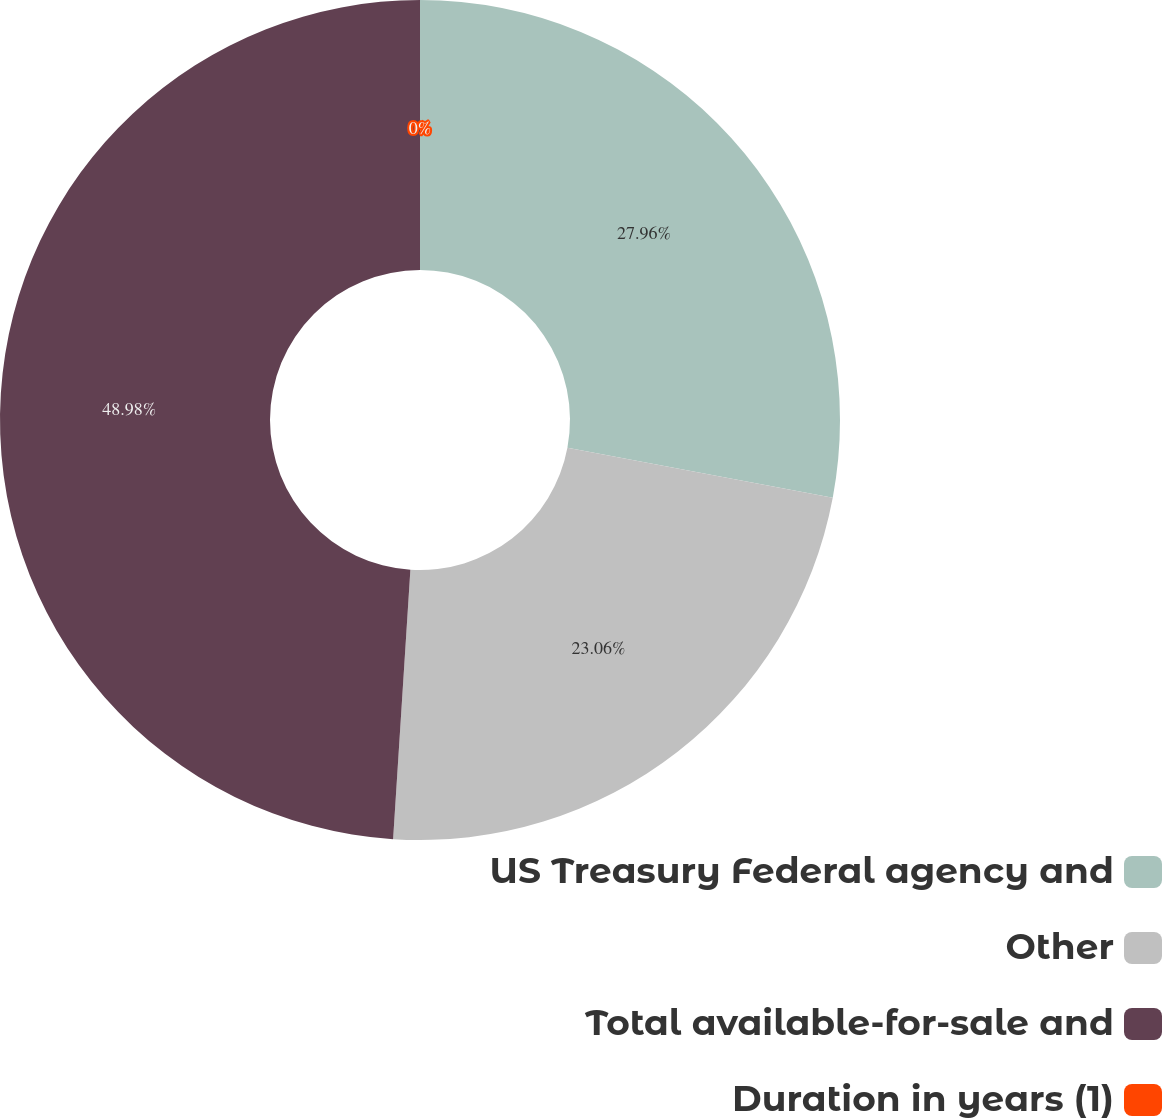Convert chart to OTSL. <chart><loc_0><loc_0><loc_500><loc_500><pie_chart><fcel>US Treasury Federal agency and<fcel>Other<fcel>Total available-for-sale and<fcel>Duration in years (1)<nl><fcel>27.96%<fcel>23.06%<fcel>48.98%<fcel>0.0%<nl></chart> 